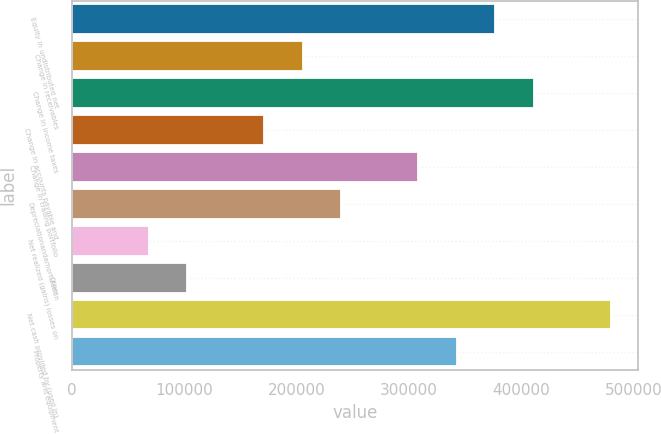Convert chart. <chart><loc_0><loc_0><loc_500><loc_500><bar_chart><fcel>Equity in undistributed net<fcel>Change in receivables<fcel>Change in income taxes<fcel>Change in accounts payable and<fcel>Change in trading portfolio<fcel>Depreciationandamortization<fcel>Net realized (gains) losses on<fcel>Other<fcel>Net cash provided by (used in)<fcel>Property and equipment<nl><fcel>376801<fcel>205546<fcel>411052<fcel>171296<fcel>308299<fcel>239797<fcel>68542.8<fcel>102794<fcel>479554<fcel>342550<nl></chart> 